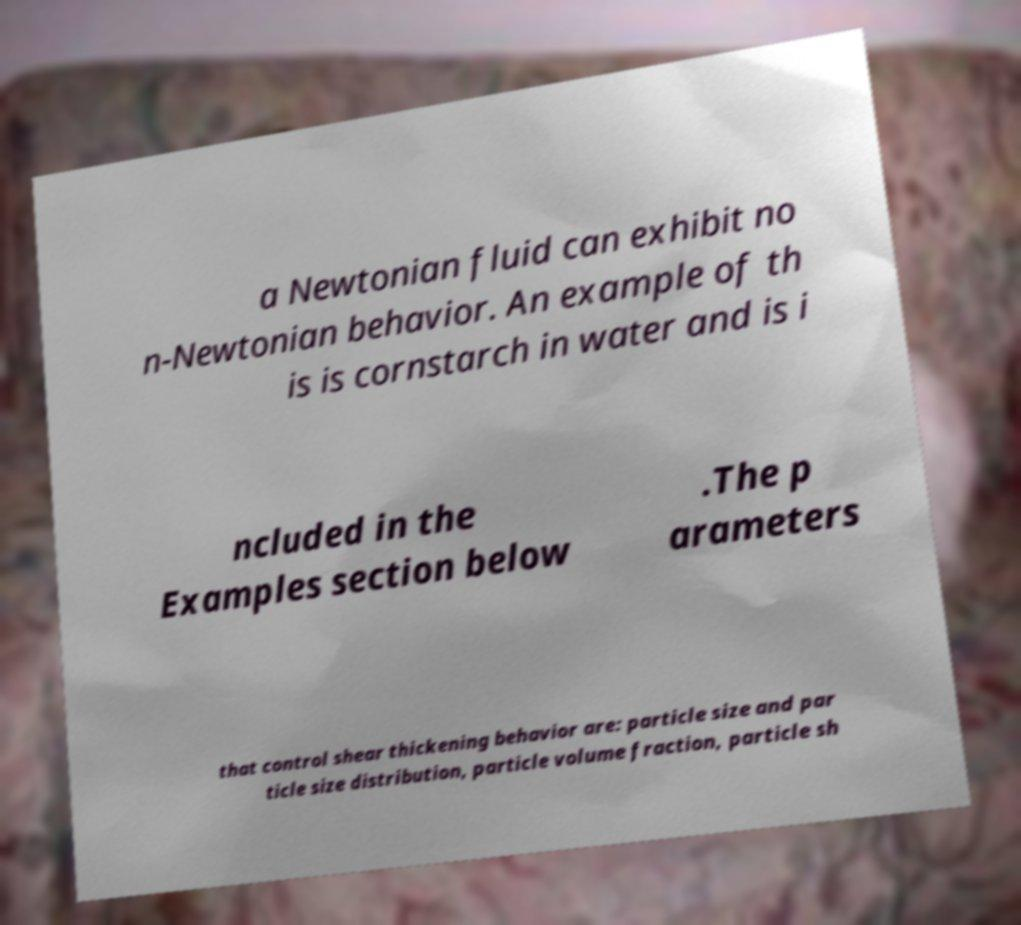For documentation purposes, I need the text within this image transcribed. Could you provide that? a Newtonian fluid can exhibit no n-Newtonian behavior. An example of th is is cornstarch in water and is i ncluded in the Examples section below .The p arameters that control shear thickening behavior are: particle size and par ticle size distribution, particle volume fraction, particle sh 